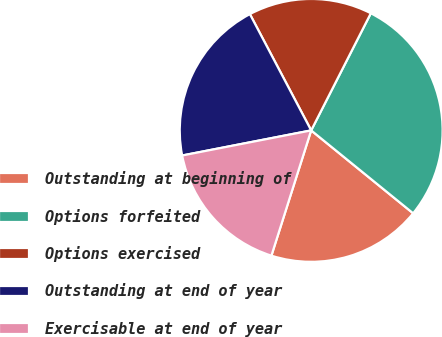Convert chart. <chart><loc_0><loc_0><loc_500><loc_500><pie_chart><fcel>Outstanding at beginning of<fcel>Options forfeited<fcel>Options exercised<fcel>Outstanding at end of year<fcel>Exercisable at end of year<nl><fcel>19.03%<fcel>28.37%<fcel>15.22%<fcel>20.34%<fcel>17.05%<nl></chart> 